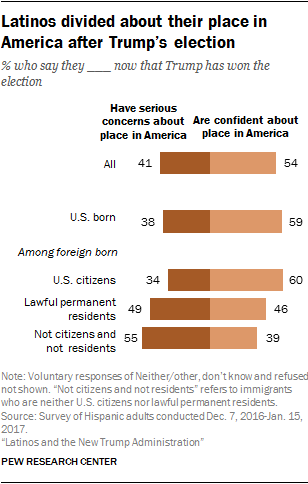How does citizenship status affect the feelings of Latinos towards their place in America after the election? From the depicted data, it appears citizenship status has a considerable impact. U.S. citizens tend to be more confident about their place in America, with 60% feeling assured. In contrast, those who are not citizens and not residents are the least confident, with 55% expressing serious concerns. 